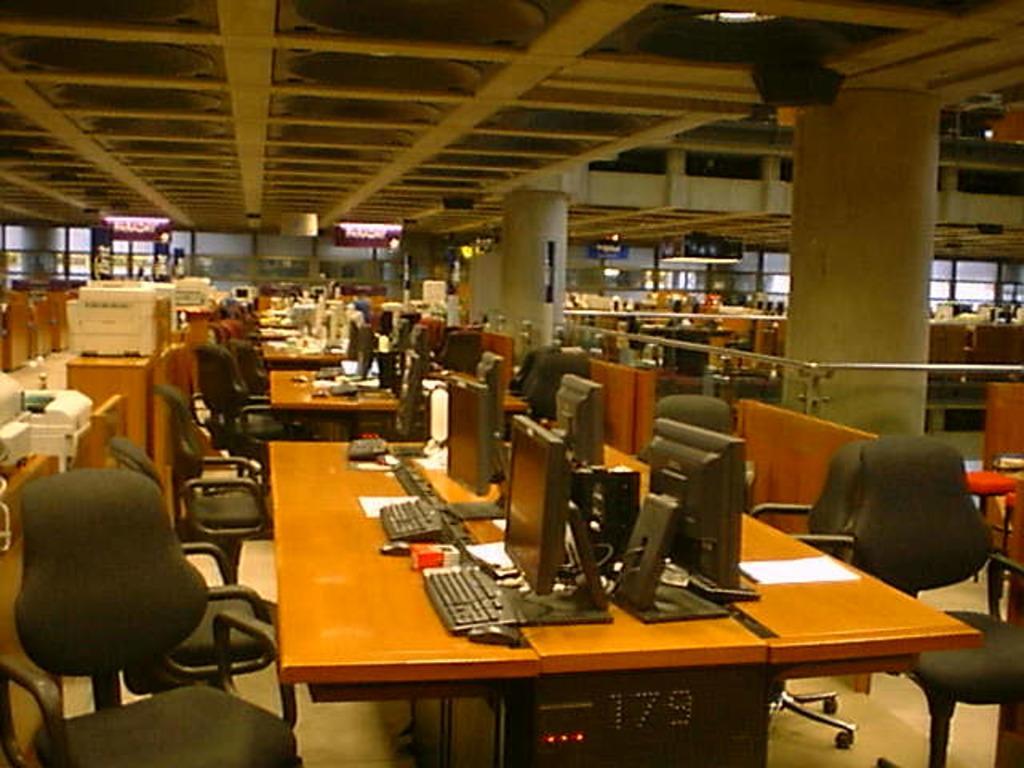In one or two sentences, can you explain what this image depicts? This is the picture of a room. In this picture there are tables and chairs and there are computers, keyboards and mouses on the tables. At the top there are lights. 